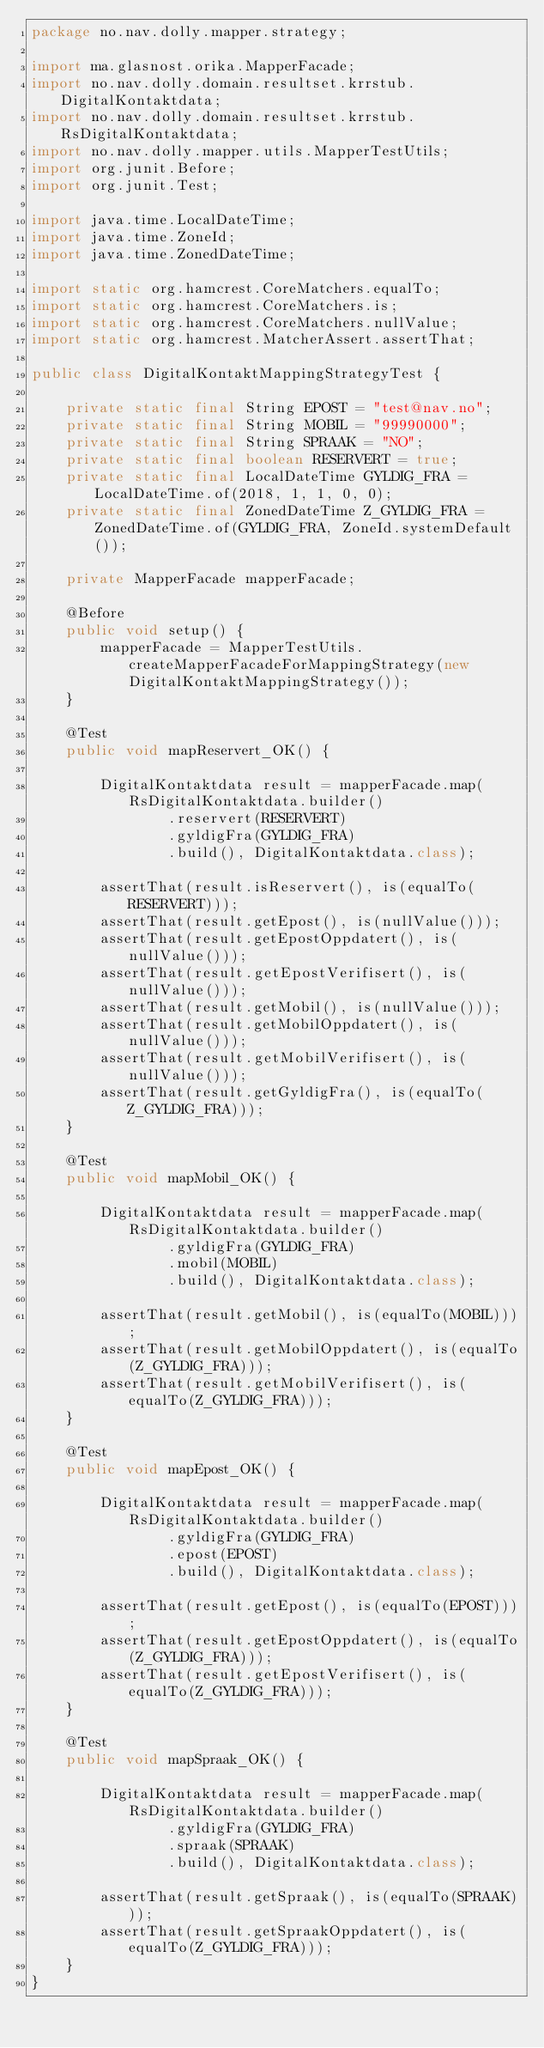Convert code to text. <code><loc_0><loc_0><loc_500><loc_500><_Java_>package no.nav.dolly.mapper.strategy;

import ma.glasnost.orika.MapperFacade;
import no.nav.dolly.domain.resultset.krrstub.DigitalKontaktdata;
import no.nav.dolly.domain.resultset.krrstub.RsDigitalKontaktdata;
import no.nav.dolly.mapper.utils.MapperTestUtils;
import org.junit.Before;
import org.junit.Test;

import java.time.LocalDateTime;
import java.time.ZoneId;
import java.time.ZonedDateTime;

import static org.hamcrest.CoreMatchers.equalTo;
import static org.hamcrest.CoreMatchers.is;
import static org.hamcrest.CoreMatchers.nullValue;
import static org.hamcrest.MatcherAssert.assertThat;

public class DigitalKontaktMappingStrategyTest {

    private static final String EPOST = "test@nav.no";
    private static final String MOBIL = "99990000";
    private static final String SPRAAK = "NO";
    private static final boolean RESERVERT = true;
    private static final LocalDateTime GYLDIG_FRA = LocalDateTime.of(2018, 1, 1, 0, 0);
    private static final ZonedDateTime Z_GYLDIG_FRA = ZonedDateTime.of(GYLDIG_FRA, ZoneId.systemDefault());

    private MapperFacade mapperFacade;

    @Before
    public void setup() {
        mapperFacade = MapperTestUtils.createMapperFacadeForMappingStrategy(new DigitalKontaktMappingStrategy());
    }

    @Test
    public void mapReservert_OK() {

        DigitalKontaktdata result = mapperFacade.map(RsDigitalKontaktdata.builder()
                .reservert(RESERVERT)
                .gyldigFra(GYLDIG_FRA)
                .build(), DigitalKontaktdata.class);

        assertThat(result.isReservert(), is(equalTo(RESERVERT)));
        assertThat(result.getEpost(), is(nullValue()));
        assertThat(result.getEpostOppdatert(), is(nullValue()));
        assertThat(result.getEpostVerifisert(), is(nullValue()));
        assertThat(result.getMobil(), is(nullValue()));
        assertThat(result.getMobilOppdatert(), is(nullValue()));
        assertThat(result.getMobilVerifisert(), is(nullValue()));
        assertThat(result.getGyldigFra(), is(equalTo(Z_GYLDIG_FRA)));
    }

    @Test
    public void mapMobil_OK() {

        DigitalKontaktdata result = mapperFacade.map(RsDigitalKontaktdata.builder()
                .gyldigFra(GYLDIG_FRA)
                .mobil(MOBIL)
                .build(), DigitalKontaktdata.class);

        assertThat(result.getMobil(), is(equalTo(MOBIL)));
        assertThat(result.getMobilOppdatert(), is(equalTo(Z_GYLDIG_FRA)));
        assertThat(result.getMobilVerifisert(), is(equalTo(Z_GYLDIG_FRA)));
    }

    @Test
    public void mapEpost_OK() {

        DigitalKontaktdata result = mapperFacade.map(RsDigitalKontaktdata.builder()
                .gyldigFra(GYLDIG_FRA)
                .epost(EPOST)
                .build(), DigitalKontaktdata.class);

        assertThat(result.getEpost(), is(equalTo(EPOST)));
        assertThat(result.getEpostOppdatert(), is(equalTo(Z_GYLDIG_FRA)));
        assertThat(result.getEpostVerifisert(), is(equalTo(Z_GYLDIG_FRA)));
    }

    @Test
    public void mapSpraak_OK() {

        DigitalKontaktdata result = mapperFacade.map(RsDigitalKontaktdata.builder()
                .gyldigFra(GYLDIG_FRA)
                .spraak(SPRAAK)
                .build(), DigitalKontaktdata.class);

        assertThat(result.getSpraak(), is(equalTo(SPRAAK)));
        assertThat(result.getSpraakOppdatert(), is(equalTo(Z_GYLDIG_FRA)));
    }
}</code> 